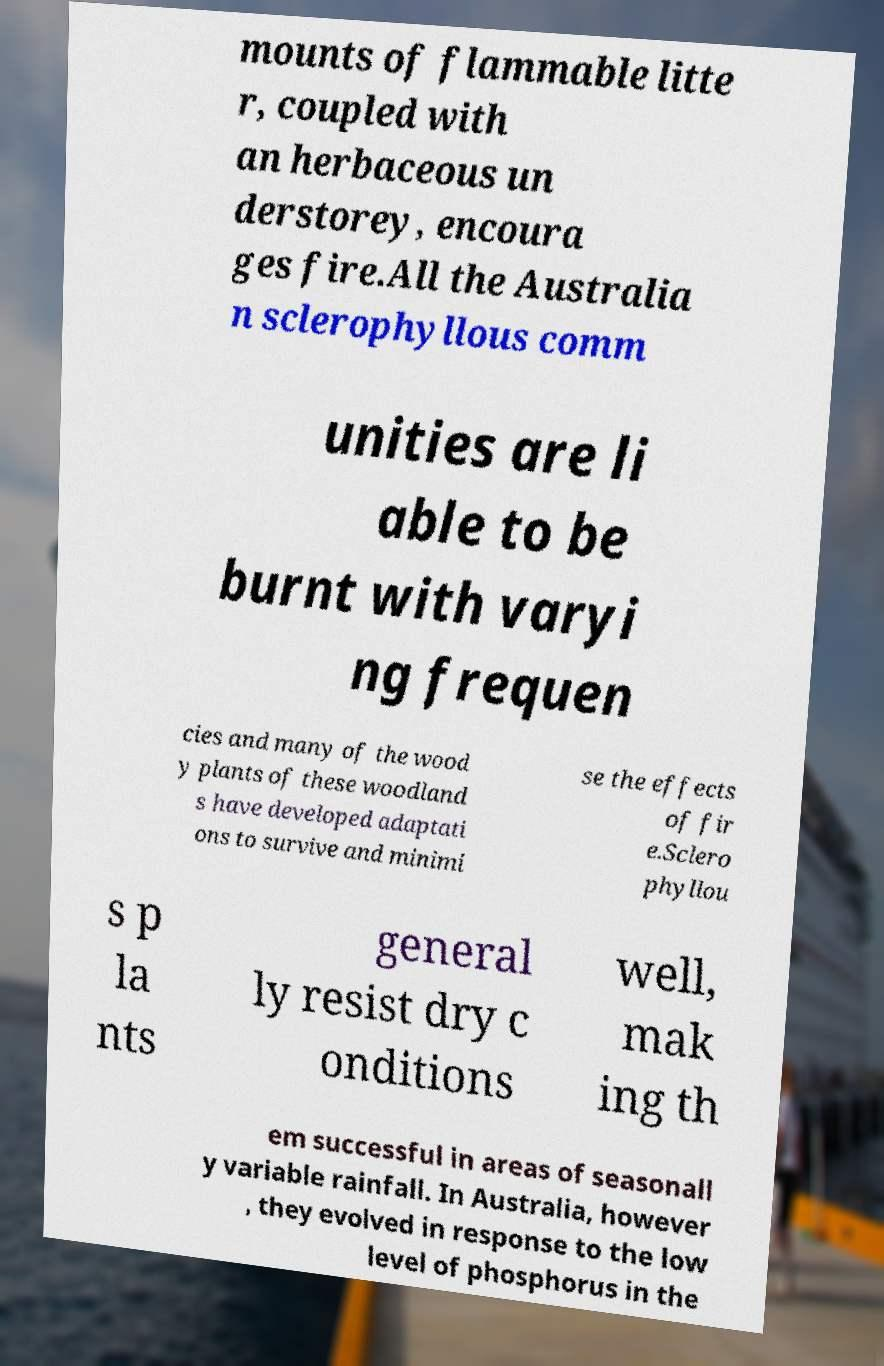There's text embedded in this image that I need extracted. Can you transcribe it verbatim? mounts of flammable litte r, coupled with an herbaceous un derstorey, encoura ges fire.All the Australia n sclerophyllous comm unities are li able to be burnt with varyi ng frequen cies and many of the wood y plants of these woodland s have developed adaptati ons to survive and minimi se the effects of fir e.Sclero phyllou s p la nts general ly resist dry c onditions well, mak ing th em successful in areas of seasonall y variable rainfall. In Australia, however , they evolved in response to the low level of phosphorus in the 